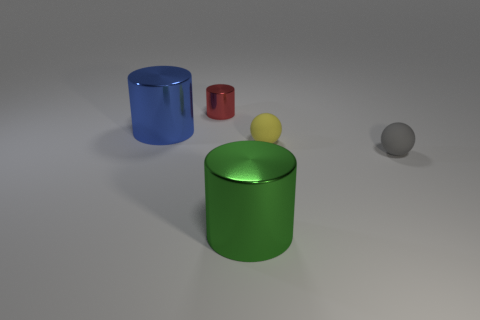What color is the tiny cylinder?
Ensure brevity in your answer.  Red. Is there another yellow thing that has the same shape as the tiny metallic thing?
Your answer should be very brief. No. There is a cylinder that is on the left side of the red cylinder; what size is it?
Provide a succinct answer. Large. There is a yellow thing that is the same size as the red metallic object; what material is it?
Offer a terse response. Rubber. Are there more matte objects than red matte balls?
Your response must be concise. Yes. There is a cylinder behind the large cylinder that is behind the gray object; how big is it?
Make the answer very short. Small. What shape is the gray matte thing that is the same size as the yellow object?
Your response must be concise. Sphere. What is the shape of the large metallic object on the right side of the large shiny thing behind the small sphere that is in front of the yellow thing?
Your response must be concise. Cylinder. Do the small sphere that is on the right side of the small yellow matte sphere and the cylinder that is left of the small red shiny cylinder have the same color?
Provide a succinct answer. No. What number of tiny gray balls are there?
Make the answer very short. 1. 